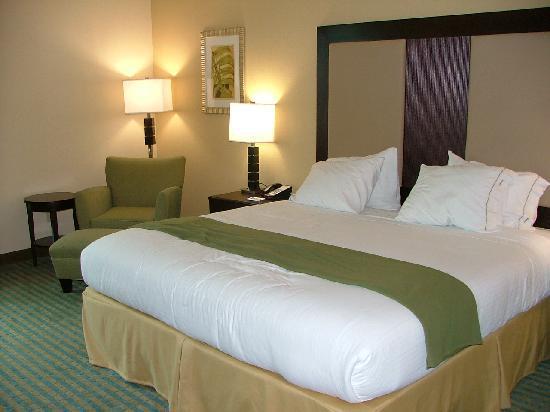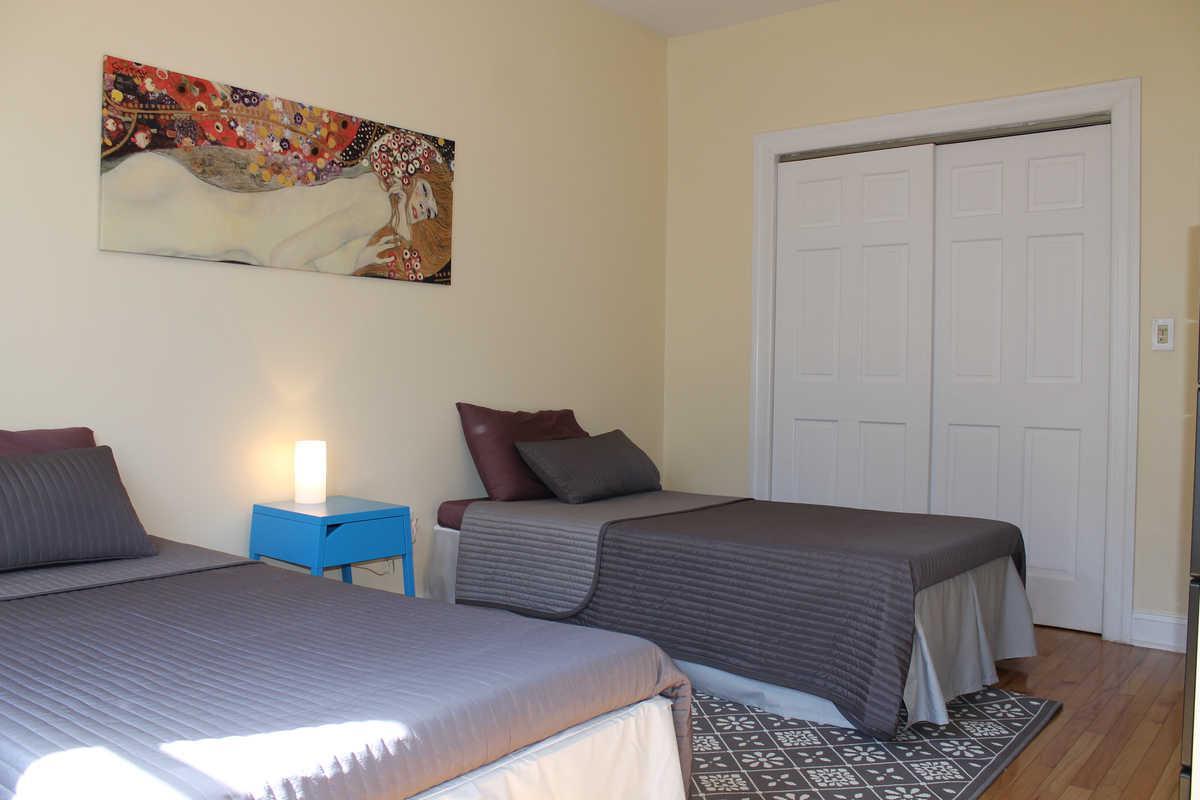The first image is the image on the left, the second image is the image on the right. Analyze the images presented: Is the assertion "One room has twin beds with gray bedding, and the other room contains one larger bed with white pillows." valid? Answer yes or no. Yes. The first image is the image on the left, the second image is the image on the right. For the images displayed, is the sentence "there are two beds in a room with a picture of a woman on the wall and a blue table between them" factually correct? Answer yes or no. Yes. 